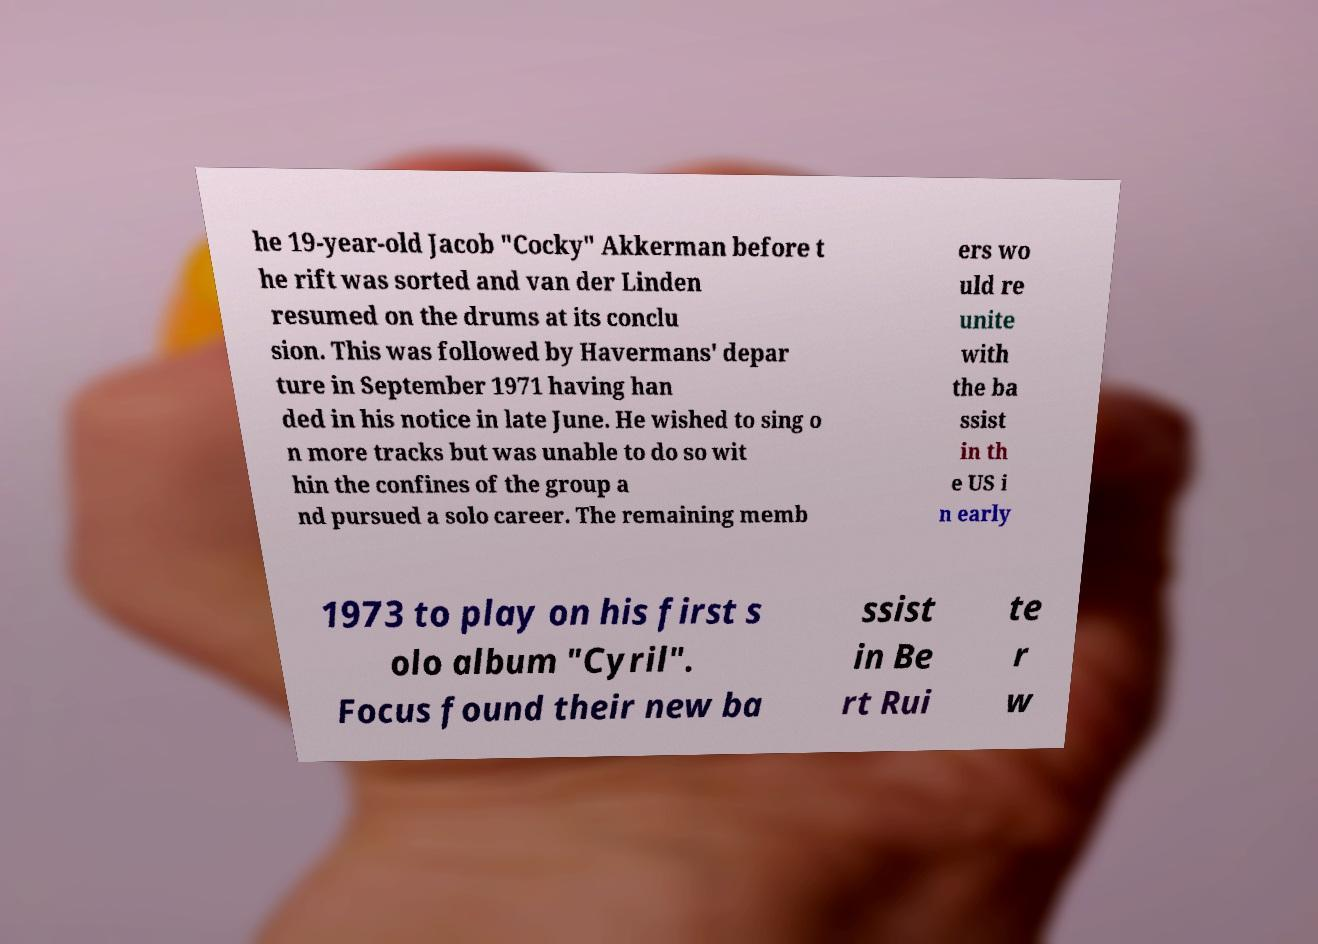Could you extract and type out the text from this image? he 19-year-old Jacob "Cocky" Akkerman before t he rift was sorted and van der Linden resumed on the drums at its conclu sion. This was followed by Havermans' depar ture in September 1971 having han ded in his notice in late June. He wished to sing o n more tracks but was unable to do so wit hin the confines of the group a nd pursued a solo career. The remaining memb ers wo uld re unite with the ba ssist in th e US i n early 1973 to play on his first s olo album "Cyril". Focus found their new ba ssist in Be rt Rui te r w 